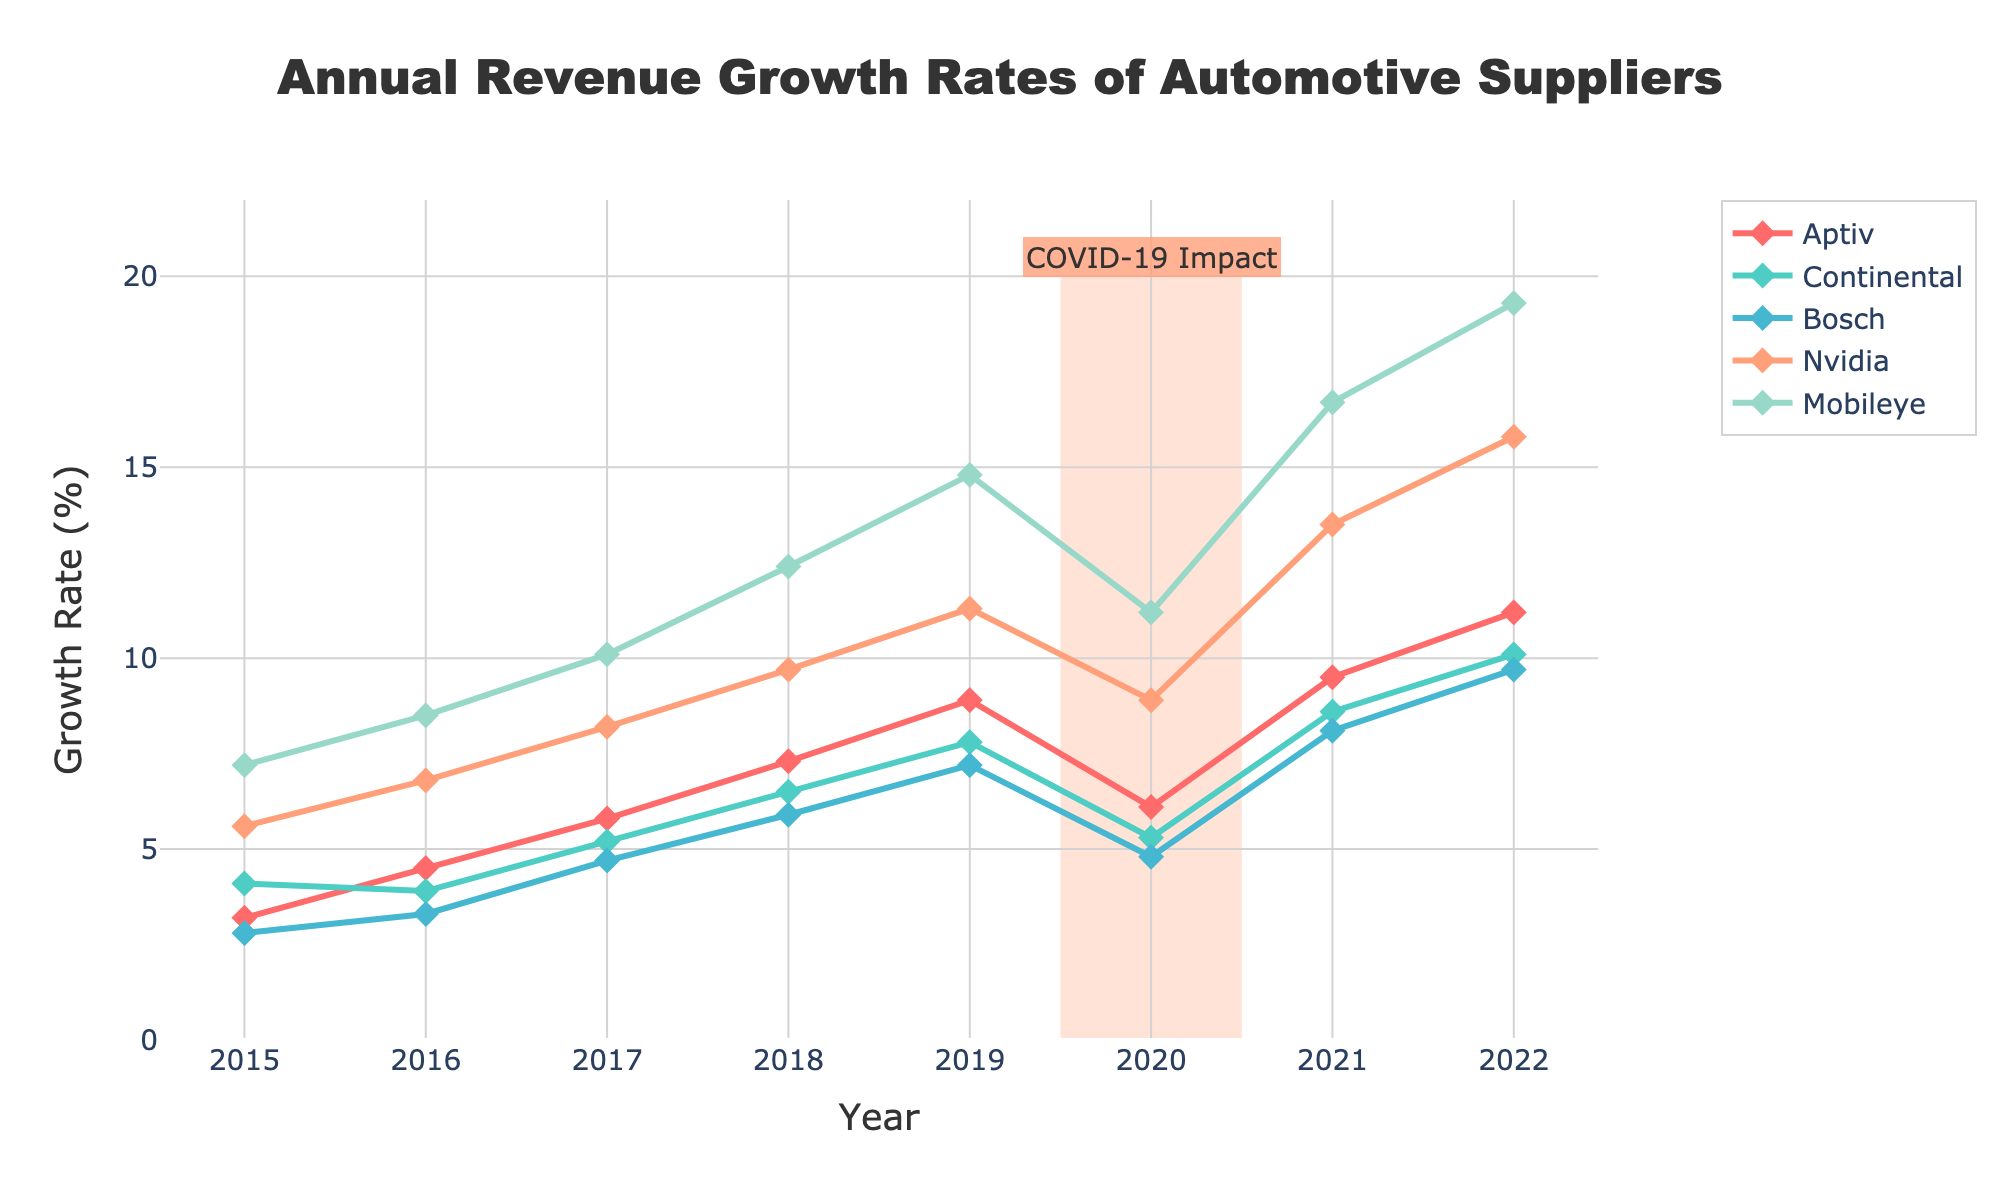What's the overall trend in the revenue growth rates of Nvidia from 2015 to 2022? To determine the overall trend, inspect the line graph for Nvidia. The graph shows an increasing trend from 2015 to 2019, a small decline in 2020, and then a sharp increase from 2021 to 2022.
Answer: Increasing overall with a small dip in 2020 How did the revenue growth rates of Mobileye change during the COVID-19 impact period (2019-2020)? Look at the Mobileye data points for 2019 and 2020. The revenue growth rate declined from 14.8% in 2019 to 11.2% in 2020.
Answer: Declined by 3.6% Which company had the highest revenue growth rate in 2022? Identify the highest data point in 2022 among all companies. Mobileye had the highest growth rate at 19.3%.
Answer: Mobileye How much did Aptiv's growth rate change between 2020 and 2021? Subtract Aptiv's growth rate in 2020 from its growth rate in 2021. The change is 9.5% - 6.1% = 3.4%.
Answer: Increased by 3.4% Compare the growth trends of Bosch and Continental between 2015 and 2022. Which company showed more consistent growth? By examining the graphs for Bosch and Continental, Bosch's growth shows a steadier and more gradual increase, while Continental's growth has more variance.
Answer: Bosch showed more consistent growth Did any company show a decline in revenue growth rate from 2021 to 2022? Check all data points from 2021 to 2022. None of the companies show a decline; all have increased growth rates.
Answer: No Which two companies had the closest revenue growth rates in 2017? Determine the growth rates for all companies in 2017 and find the smallest difference. Bosch and Continental were closest with rates of 4.7% and 5.2%, respectively.
Answer: Bosch and Continental What was the average revenue growth rate of Aptiv from 2015 to 2022? Sum all yearly growth rates for Aptiv and divide by the number of years. (3.2 + 4.5 + 5.8 + 7.3 + 8.9 + 6.1 + 9.5 + 11.2) / 8 ≈ 7.06℅.
Answer: 7.06% Which company's growth was least affected by the COVID-19 impact period? Compare the change in growth rates from 2019 to 2020. Continental's rate dropped the least (from 7.8% to 5.3%, a difference of 2.5%).
Answer: Continental How many companies had a revenue growth rate greater than 10% in 2022? Identify the companies with growth rates above 10% in 2022. There are three companies: Continental, Bosch, Nvidia, and Mobileye.
Answer: Four 